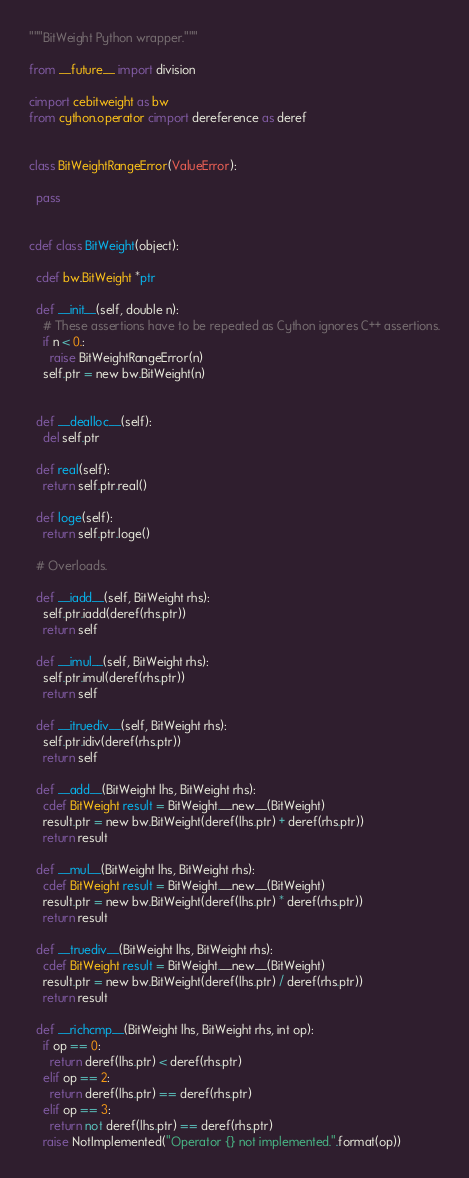Convert code to text. <code><loc_0><loc_0><loc_500><loc_500><_Cython_>"""BitWeight Python wrapper."""

from __future__ import division

cimport cebitweight as bw
from cython.operator cimport dereference as deref


class BitWeightRangeError(ValueError):

  pass


cdef class BitWeight(object):

  cdef bw.BitWeight *ptr
	
  def __init__(self, double n):
    # These assertions have to be repeated as Cython ignores C++ assertions.
    if n < 0.:
      raise BitWeightRangeError(n)
    self.ptr = new bw.BitWeight(n) 
	

  def __dealloc__(self):
    del self.ptr

  def real(self):
    return self.ptr.real()

  def loge(self):
    return self.ptr.loge()
	
  # Overloads.

  def __iadd__(self, BitWeight rhs):
    self.ptr.iadd(deref(rhs.ptr))
    return self

  def __imul__(self, BitWeight rhs):
    self.ptr.imul(deref(rhs.ptr))
    return self

  def __itruediv__(self, BitWeight rhs):
    self.ptr.idiv(deref(rhs.ptr))
    return self

  def __add__(BitWeight lhs, BitWeight rhs):
    cdef BitWeight result = BitWeight.__new__(BitWeight)
    result.ptr = new bw.BitWeight(deref(lhs.ptr) + deref(rhs.ptr))
    return result

  def __mul__(BitWeight lhs, BitWeight rhs):
    cdef BitWeight result = BitWeight.__new__(BitWeight)
    result.ptr = new bw.BitWeight(deref(lhs.ptr) * deref(rhs.ptr))
    return result

  def __truediv__(BitWeight lhs, BitWeight rhs):
    cdef BitWeight result = BitWeight.__new__(BitWeight)
    result.ptr = new bw.BitWeight(deref(lhs.ptr) / deref(rhs.ptr))
    return result

  def __richcmp__(BitWeight lhs, BitWeight rhs, int op):
    if op == 0:
      return deref(lhs.ptr) < deref(rhs.ptr)
    elif op == 2:
      return deref(lhs.ptr) == deref(rhs.ptr)
    elif op == 3:
      return not deref(lhs.ptr) == deref(rhs.ptr)
    raise NotImplemented("Operator {} not implemented.".format(op))
</code> 